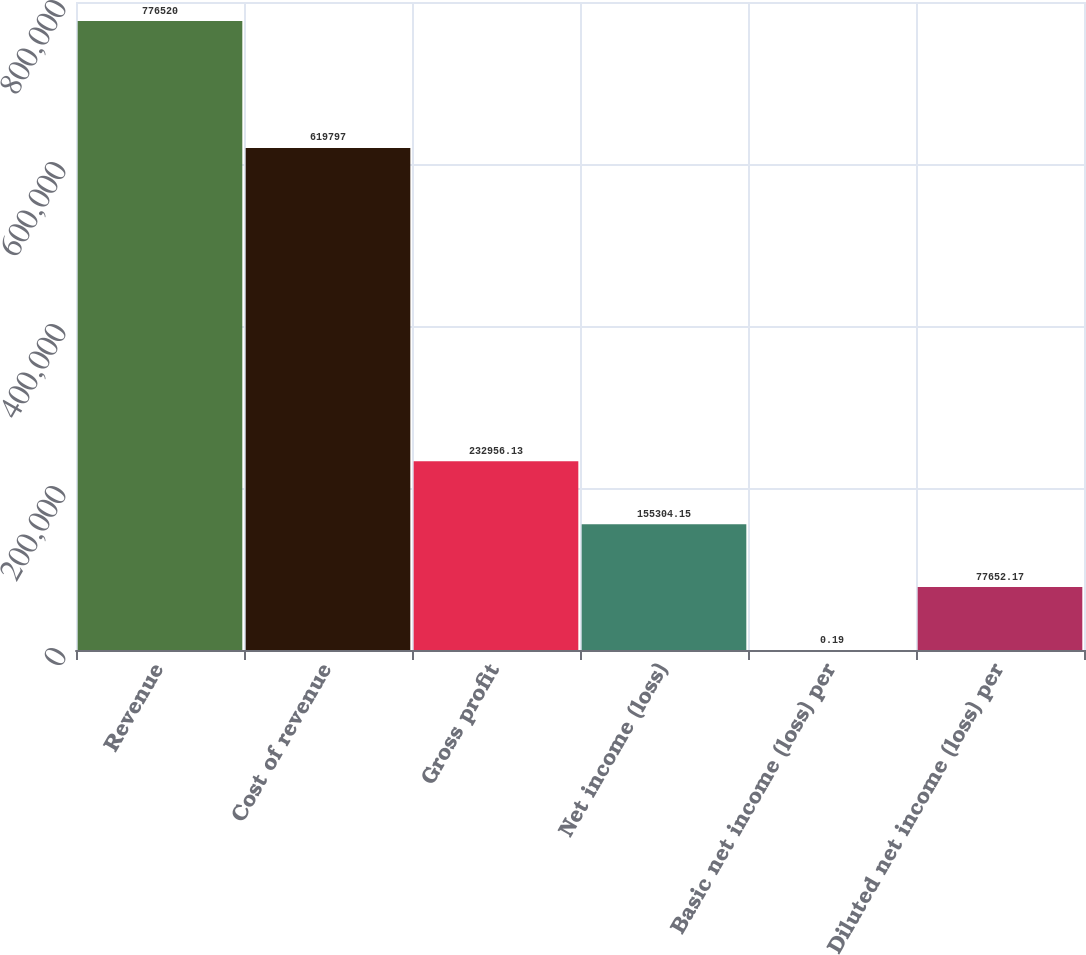<chart> <loc_0><loc_0><loc_500><loc_500><bar_chart><fcel>Revenue<fcel>Cost of revenue<fcel>Gross profit<fcel>Net income (loss)<fcel>Basic net income (loss) per<fcel>Diluted net income (loss) per<nl><fcel>776520<fcel>619797<fcel>232956<fcel>155304<fcel>0.19<fcel>77652.2<nl></chart> 